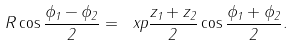<formula> <loc_0><loc_0><loc_500><loc_500>R \cos \frac { \phi _ { 1 } - \phi _ { 2 } } { 2 } = \ x p \frac { z _ { 1 } + z _ { 2 } } { 2 } \cos \frac { \phi _ { 1 } + \phi _ { 2 } } { 2 } .</formula> 